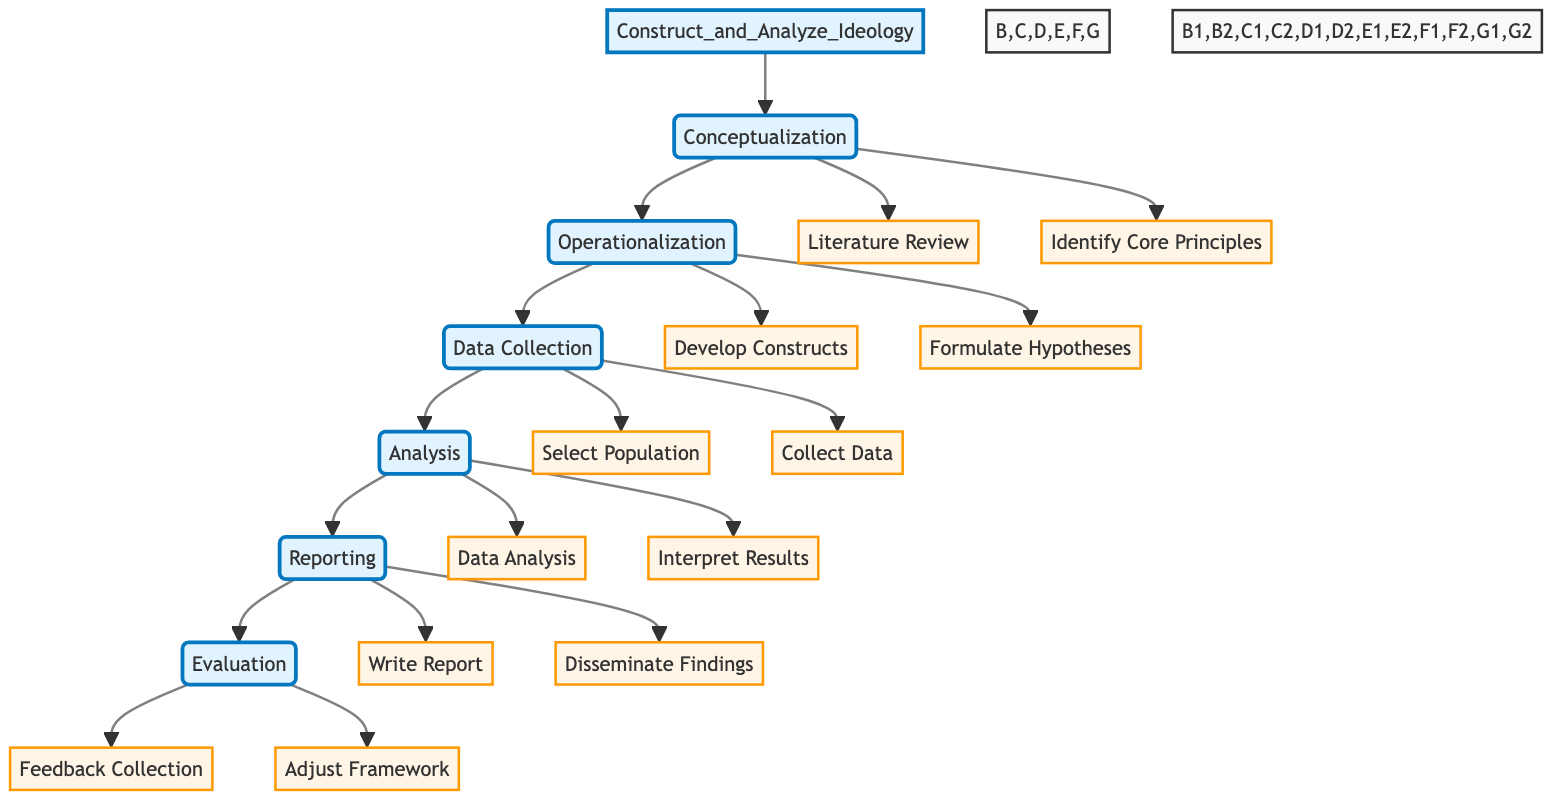What is the first step in the ideology construction process? The diagram indicates that the first step in the process is "Conceptualization." This is inferred from the directional flow starting from the main function node "Construct_and_Analyze_Ideology," which leads to the first step, labeled as "Conceptualization."
Answer: Conceptualization How many main steps are outlined in the flowchart? The flowchart contains six main steps, as identified by the nodes leading sequentially from "Construct_and_Analyze_Ideology" toward "Evaluation." Counting each main labeled node confirms this total.
Answer: Six Which task follows "Collect Data" in the diagram? The diagram shows that "Data Analysis" is the task that follows "Collect Data." This can be seen directly in the sequence of tasks outlined under the "Data Collection" and "Analysis" steps.
Answer: Data Analysis What resources are listed for "Literature Review"? The diagram denotes three resources for the task "Literature Review," which are "Books," "Academic Journals," and "Philosophers' Writings." This information is specifically provided alongside the task label in the flowchart.
Answer: Books, Academic Journals, Philosophers' Writings What is the relationship between "Feedback Collection" and "Adjust Framework"? "Feedback Collection" and "Adjust Framework" are both sub-elements under the "Evaluation" step in the diagram. They are connected sequentially, indicating that feedback collection informs the adjustment of the framework.
Answer: Sequential relationship In which step are "Develop Constructs" and "Formulate Hypotheses" located? Both tasks are found in the "Operationalization" step, which can be identified as the second main step in the flowchart through the visual layout and connections stemming from the "Construct_and_Analyze_Ideology" node.
Answer: Operationalization How many tasks are in the "Analysis" step? There are two tasks in the "Analysis" step: "Data Analysis" and "Interpret Results." This is identifiable by counting the sub-elements in the "Analysis" section of the flowchart.
Answer: Two What is the last task in the research process according to the diagram? The last task in the process, as outlined by the flowchart, is "Adjust Framework." This is positioned last in the sequence under the "Evaluation" step, indicating it concludes the process after "Feedback Collection."
Answer: Adjust Framework What type of framework is suggested for refining based on feedback? The diagram suggests that "Theoretical Framework" is what should be refined based on the feedback collected. The connection of this task under the "Evaluation" step points to it directly.
Answer: Theoretical Framework 